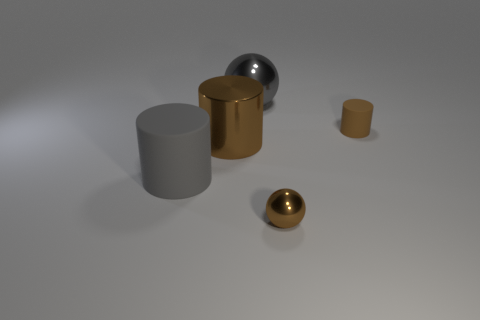Add 5 large things. How many objects exist? 10 Subtract all small brown rubber cylinders. How many cylinders are left? 2 Add 1 large red shiny cylinders. How many large red shiny cylinders exist? 1 Subtract all gray cylinders. How many cylinders are left? 2 Subtract 0 green cylinders. How many objects are left? 5 Subtract all balls. How many objects are left? 3 Subtract all cyan cylinders. Subtract all red spheres. How many cylinders are left? 3 Subtract all gray blocks. How many purple cylinders are left? 0 Subtract all big green rubber cylinders. Subtract all gray shiny balls. How many objects are left? 4 Add 3 gray things. How many gray things are left? 5 